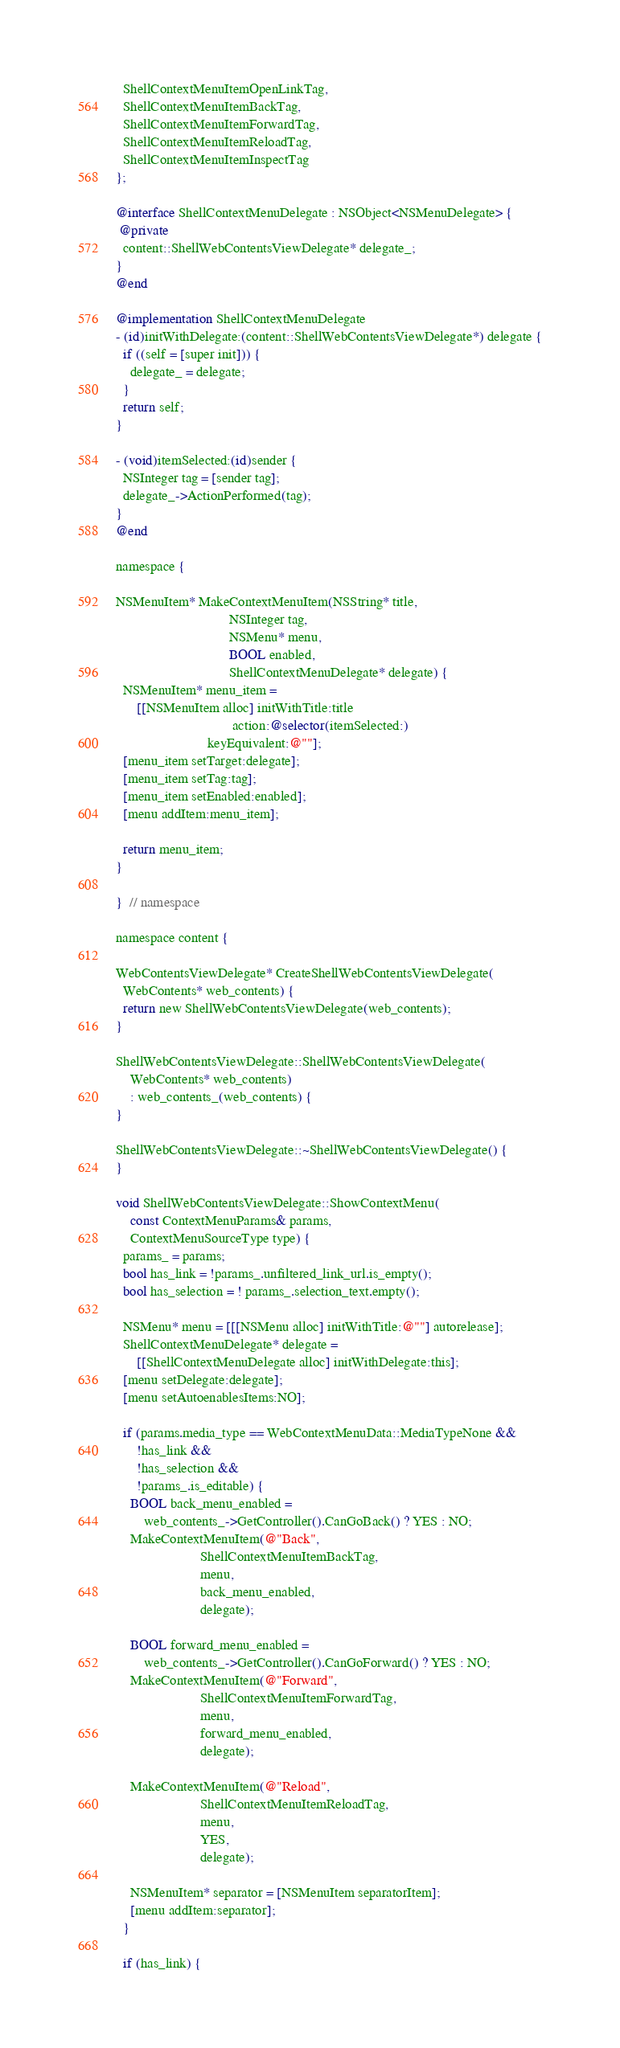Convert code to text. <code><loc_0><loc_0><loc_500><loc_500><_ObjectiveC_>  ShellContextMenuItemOpenLinkTag,
  ShellContextMenuItemBackTag,
  ShellContextMenuItemForwardTag,
  ShellContextMenuItemReloadTag,
  ShellContextMenuItemInspectTag
};

@interface ShellContextMenuDelegate : NSObject<NSMenuDelegate> {
 @private
  content::ShellWebContentsViewDelegate* delegate_;
}
@end

@implementation ShellContextMenuDelegate
- (id)initWithDelegate:(content::ShellWebContentsViewDelegate*) delegate {
  if ((self = [super init])) {
    delegate_ = delegate;
  }
  return self;
}

- (void)itemSelected:(id)sender {
  NSInteger tag = [sender tag];
  delegate_->ActionPerformed(tag);
}
@end

namespace {

NSMenuItem* MakeContextMenuItem(NSString* title,
                                NSInteger tag,
                                NSMenu* menu,
                                BOOL enabled,
                                ShellContextMenuDelegate* delegate) {
  NSMenuItem* menu_item =
      [[NSMenuItem alloc] initWithTitle:title
                                 action:@selector(itemSelected:)
                          keyEquivalent:@""];
  [menu_item setTarget:delegate];
  [menu_item setTag:tag];
  [menu_item setEnabled:enabled];
  [menu addItem:menu_item];

  return menu_item;
}

}  // namespace

namespace content {

WebContentsViewDelegate* CreateShellWebContentsViewDelegate(
  WebContents* web_contents) {
  return new ShellWebContentsViewDelegate(web_contents);
}

ShellWebContentsViewDelegate::ShellWebContentsViewDelegate(
    WebContents* web_contents)
    : web_contents_(web_contents) {
}

ShellWebContentsViewDelegate::~ShellWebContentsViewDelegate() {
}

void ShellWebContentsViewDelegate::ShowContextMenu(
    const ContextMenuParams& params,
    ContextMenuSourceType type) {
  params_ = params;
  bool has_link = !params_.unfiltered_link_url.is_empty();
  bool has_selection = ! params_.selection_text.empty();

  NSMenu* menu = [[[NSMenu alloc] initWithTitle:@""] autorelease];
  ShellContextMenuDelegate* delegate =
      [[ShellContextMenuDelegate alloc] initWithDelegate:this];
  [menu setDelegate:delegate];
  [menu setAutoenablesItems:NO];

  if (params.media_type == WebContextMenuData::MediaTypeNone &&
      !has_link &&
      !has_selection &&
      !params_.is_editable) {
    BOOL back_menu_enabled =
        web_contents_->GetController().CanGoBack() ? YES : NO;
    MakeContextMenuItem(@"Back",
                        ShellContextMenuItemBackTag,
                        menu,
                        back_menu_enabled,
                        delegate);

    BOOL forward_menu_enabled =
        web_contents_->GetController().CanGoForward() ? YES : NO;
    MakeContextMenuItem(@"Forward",
                        ShellContextMenuItemForwardTag,
                        menu,
                        forward_menu_enabled,
                        delegate);

    MakeContextMenuItem(@"Reload",
                        ShellContextMenuItemReloadTag,
                        menu,
                        YES,
                        delegate);

    NSMenuItem* separator = [NSMenuItem separatorItem];
    [menu addItem:separator];
  }

  if (has_link) {</code> 